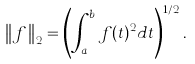<formula> <loc_0><loc_0><loc_500><loc_500>\left \| f \right \| _ { 2 } = \left ( \int _ { a } ^ { b } f ( t ) ^ { 2 } d t \right ) ^ { 1 / 2 } .</formula> 